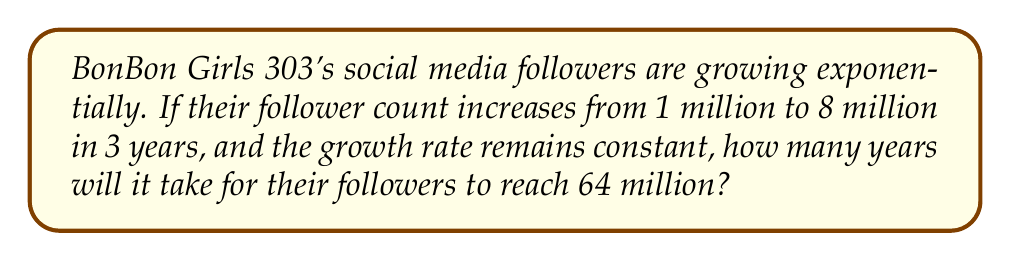Teach me how to tackle this problem. Let's approach this step-by-step using logarithms:

1) Let $y$ be the number of years and $r$ be the annual growth rate.

2) The exponential growth formula is:
   $A = P(1+r)^t$
   where $A$ is the final amount, $P$ is the initial amount, $r$ is the growth rate, and $t$ is time.

3) From the given information:
   $8 = 1(1+r)^3$

4) Simplify:
   $8 = (1+r)^3$

5) Take the cube root of both sides:
   $2 = 1+r$

6) Solve for $r$:
   $r = 1$ or 100%

7) Now, let's use this rate to find how long it will take to reach 64 million:
   $64 = 1(1+1)^y$

8) Simplify:
   $64 = 2^y$

9) Take the logarithm of both sides:
   $\log_2 64 = \log_2 2^y$

10) Simplify the right side:
    $\log_2 64 = y$

11) Calculate:
    $y = 6$

Therefore, it will take 6 years for the followers to reach 64 million.
Answer: 6 years 